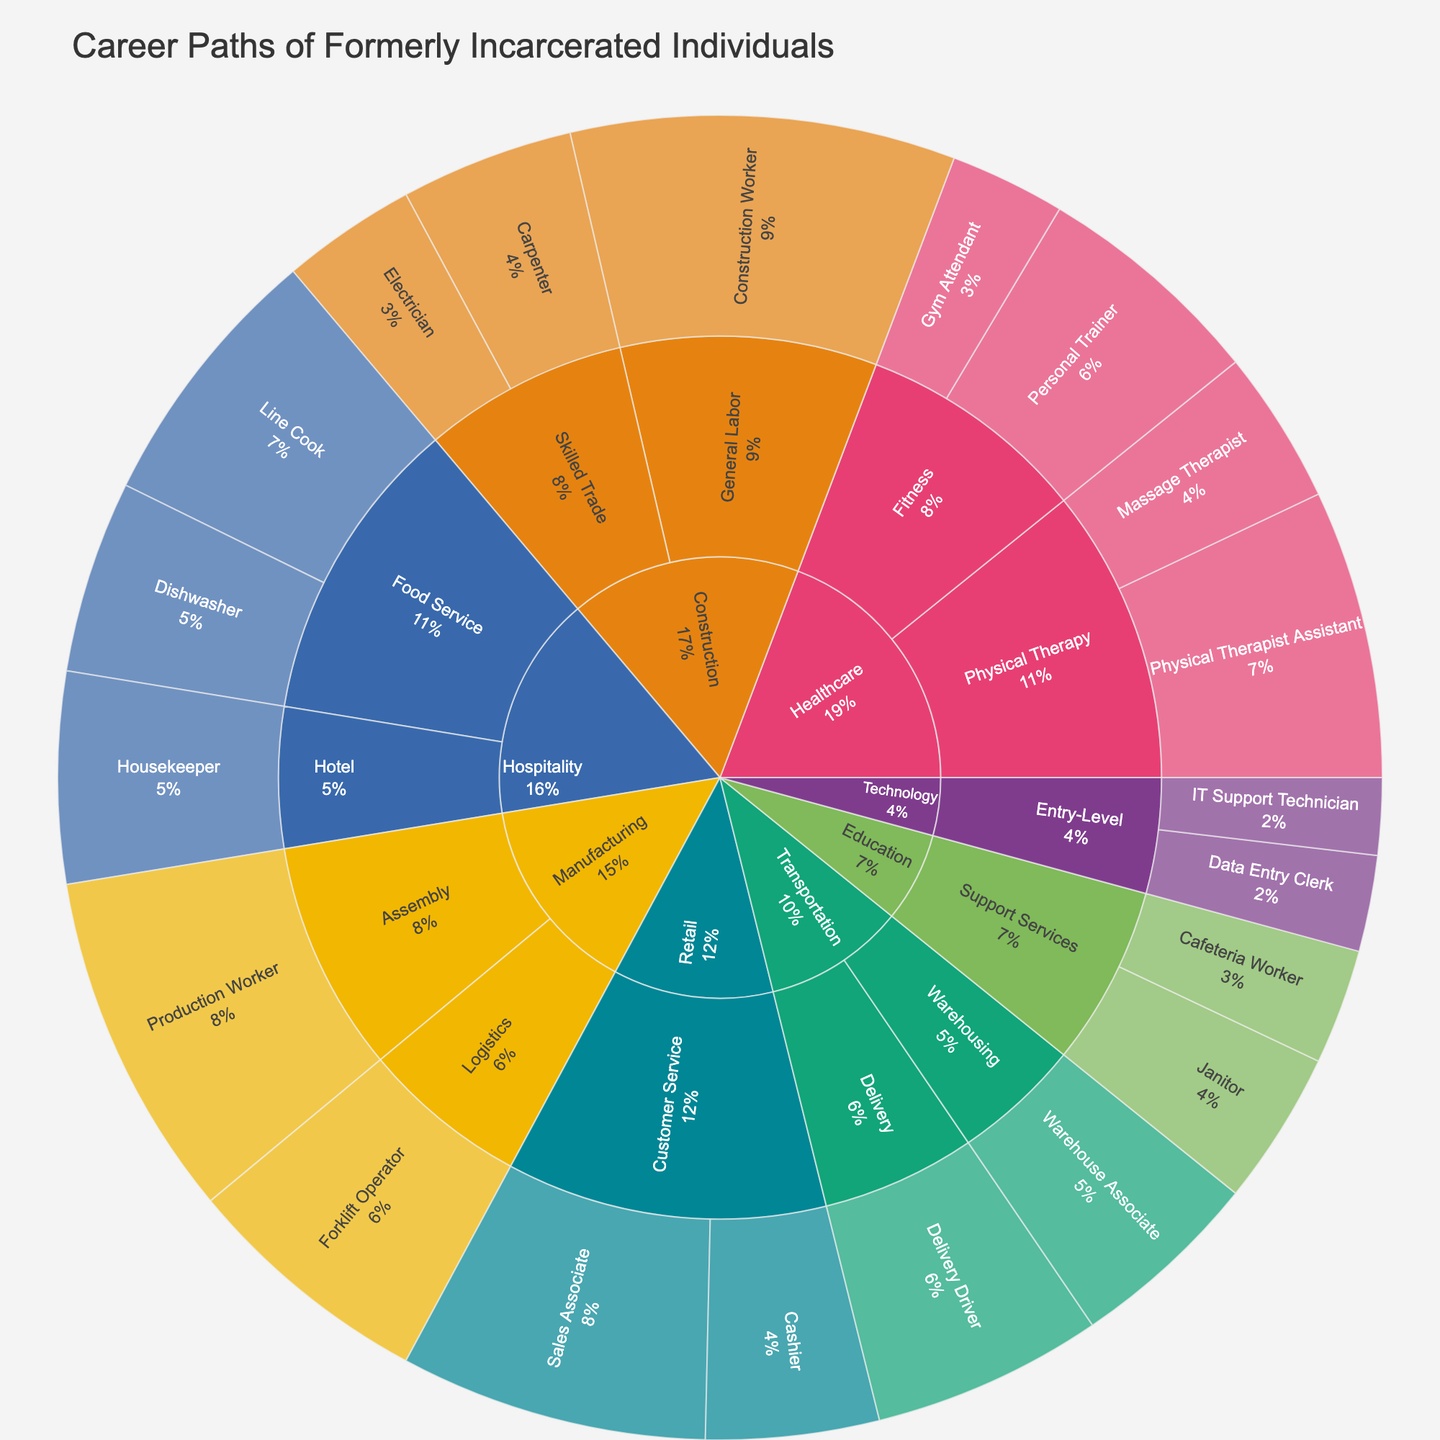What's the overall title of the figure? The title is usually located at the top of the plot, clearly stated to describe the visualized data. In this case, we look at the top and see "Career Paths of Formerly Incarcerated Individuals".
Answer: Career Paths of Formerly Incarcerated Individuals Which industry has the highest number of former inmates employed? To answer this, we identify the largest segment representing an industry. The largest segment is for "Construction" with a sum of job roles under it. Specifically, the counts are 20 (Construction Worker) + 7 (Electrician) + 9 (Carpenter), which totals 36.
Answer: Construction What job role has the highest count in Manufacturing? We look at the sub-segments under the "Manufacturing" industry sector. Summing the counts for each role, Production Worker has 18 and Forklift Operator has 13, with Production Worker having the highest count.
Answer: Production Worker How many job roles are listed under the Healthcare industry? To find this, we count all distinct job roles under the Healthcare sector. These are Physical Therapist Assistant, Massage Therapist, Personal Trainer, and Gym Attendant, totaling 4.
Answer: 4 Which industry has the smallest number of roles, and what are these roles? By examining the segments under each industry, Technology has the smallest number of roles. There are two roles listed: Data Entry Clerk and IT Support Technician.
Answer: Technology; Data Entry Clerk, IT Support Technician Which job role in the Retail industry has more employees and by how much? Within the Retail industry, the job roles are Sales Associate and Cashier with counts of 16 and 9 respectively. The difference is 16 - 9 = 7.
Answer: Sales Associate, by 7 What percentage of employees in the Hospitality industry work in the Food Service sector? First, sum the counts for the Food Service and Hotel sectors. Food Service: 14 (Line Cook) + 10 (Dishwasher) = 24; Hotel: 11 (Housekeeper). Total in Hospitality: 24 + 11 = 35. Percentage for Food Service is (24/35) * 100 = approximately 68.57%.
Answer: Approximately 68.57% How does the count of Personal Trainers compare to the count of Construction Workers? The number of Personal Trainers is 12, and there are 20 Construction Workers. Construction Workers outnumber Personal Trainers by 20 - 12 = 8.
Answer: Construction Workers by 8 What is the sum of the counts for all job roles under the Technology industry? Sum the counts for each job role under Technology: 5 (Data Entry Clerk) + 4 (IT Support Technician) = 9.
Answer: 9 How many job roles in total are represented in the entire plot? We count the total number of distinct job roles in the dataset which are listed under all industries and sectors. There are 18 distinct job roles.
Answer: 18 